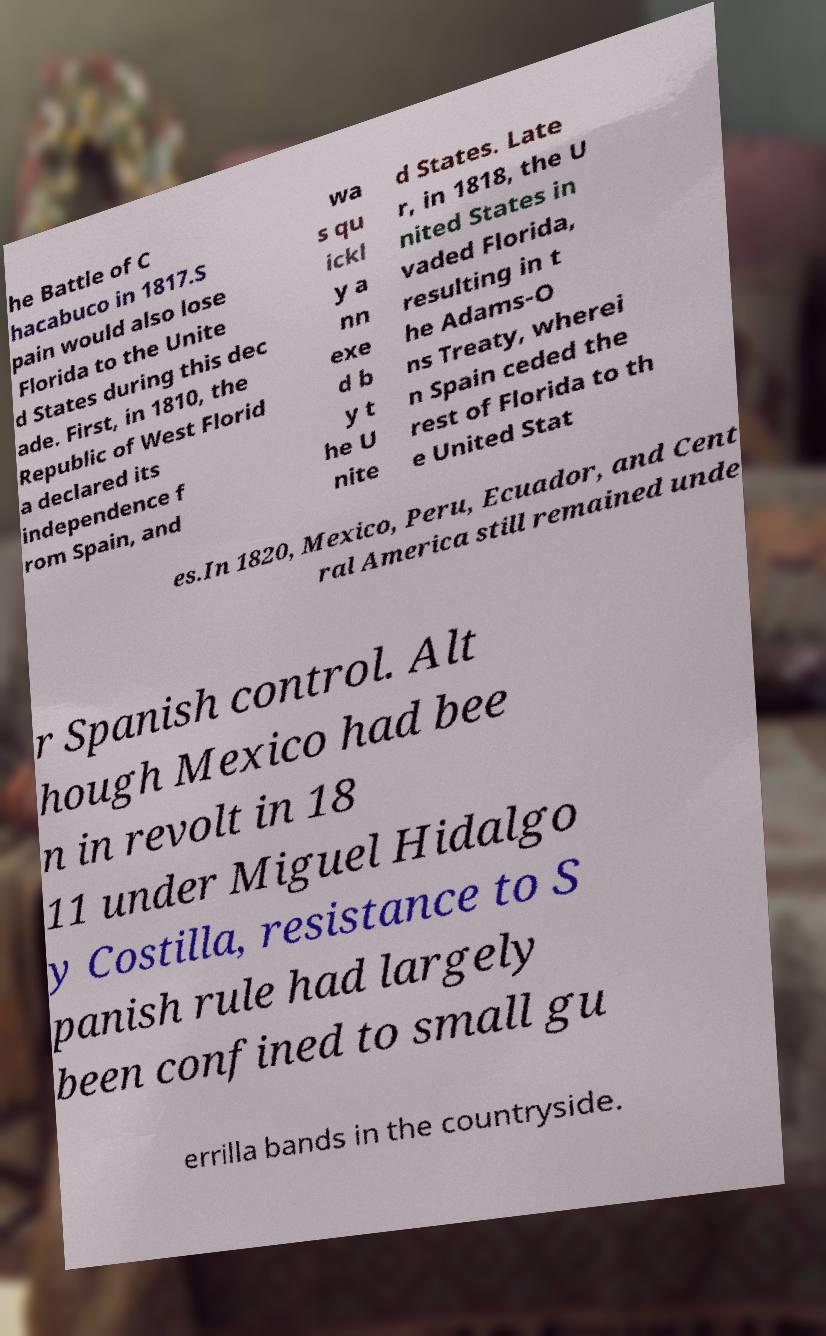There's text embedded in this image that I need extracted. Can you transcribe it verbatim? he Battle of C hacabuco in 1817.S pain would also lose Florida to the Unite d States during this dec ade. First, in 1810, the Republic of West Florid a declared its independence f rom Spain, and wa s qu ickl y a nn exe d b y t he U nite d States. Late r, in 1818, the U nited States in vaded Florida, resulting in t he Adams-O ns Treaty, wherei n Spain ceded the rest of Florida to th e United Stat es.In 1820, Mexico, Peru, Ecuador, and Cent ral America still remained unde r Spanish control. Alt hough Mexico had bee n in revolt in 18 11 under Miguel Hidalgo y Costilla, resistance to S panish rule had largely been confined to small gu errilla bands in the countryside. 